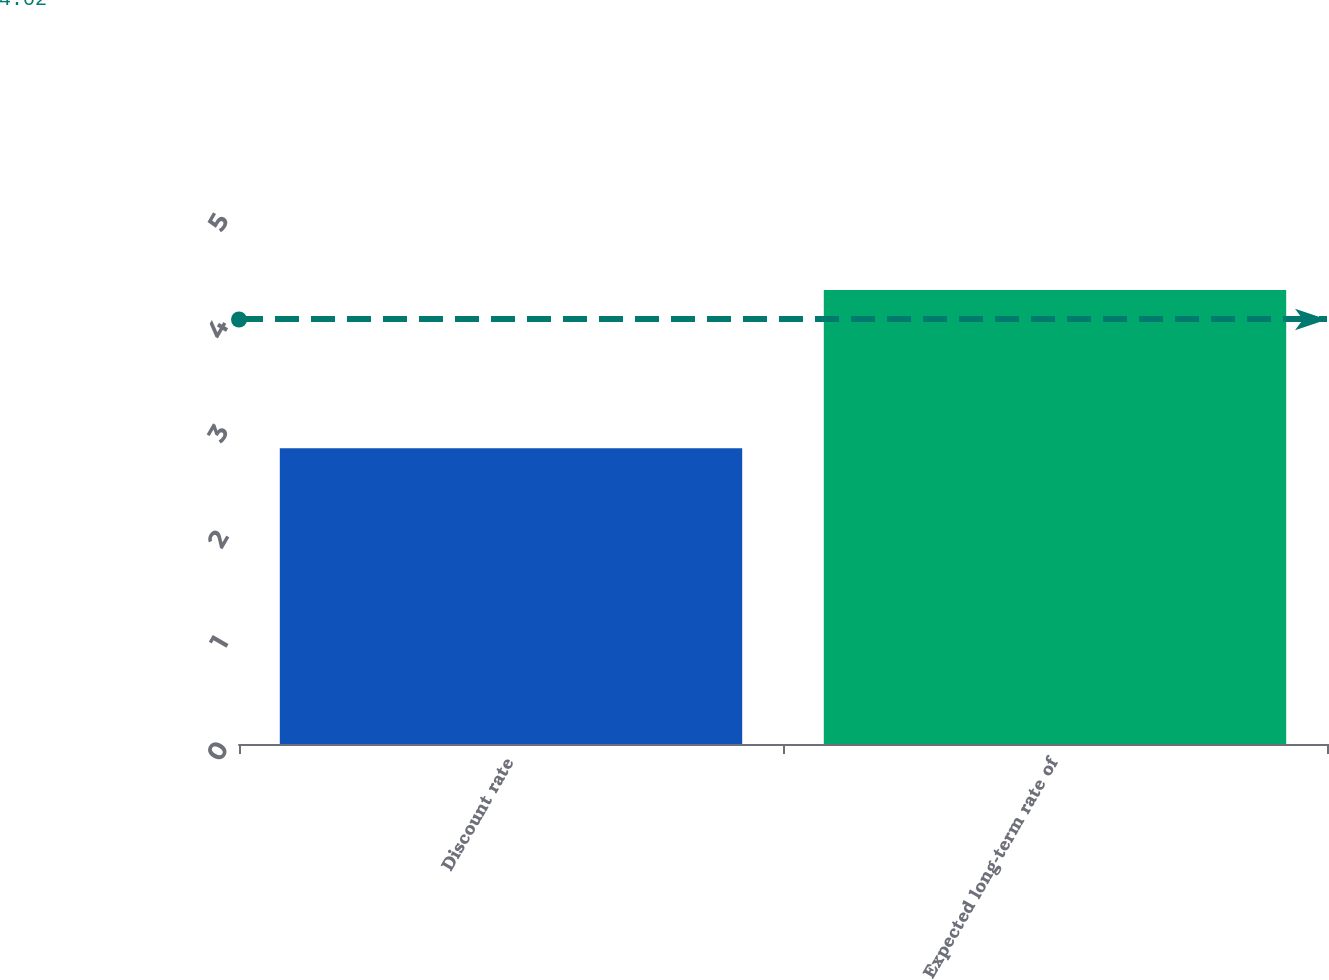Convert chart. <chart><loc_0><loc_0><loc_500><loc_500><bar_chart><fcel>Discount rate<fcel>Expected long-term rate of<nl><fcel>2.8<fcel>4.3<nl></chart> 